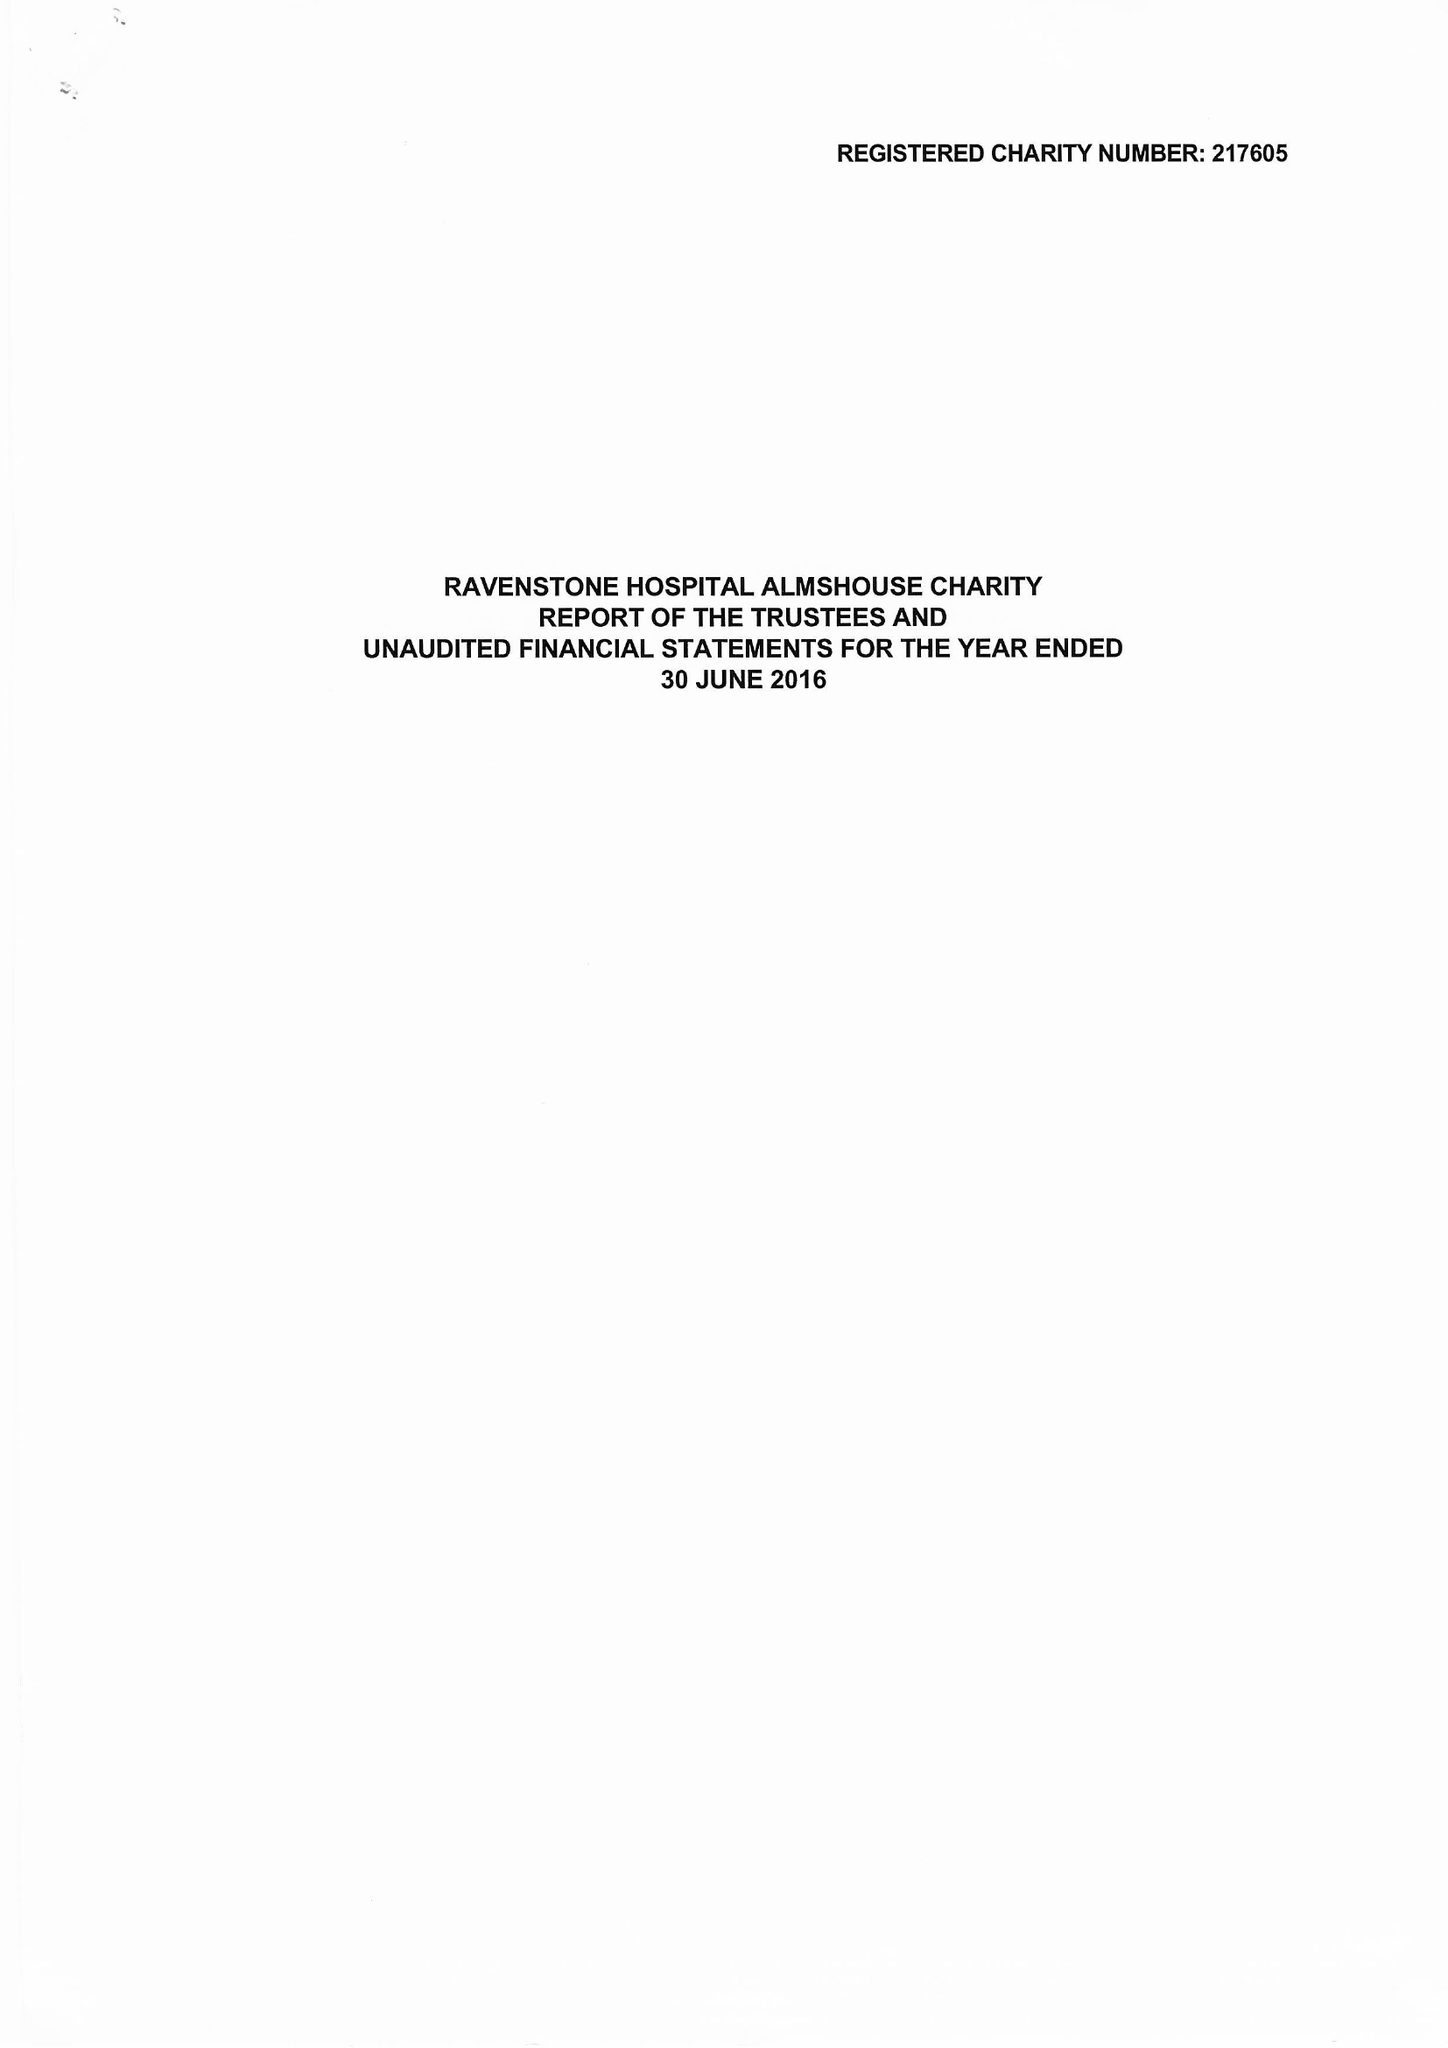What is the value for the charity_number?
Answer the question using a single word or phrase. 217605 